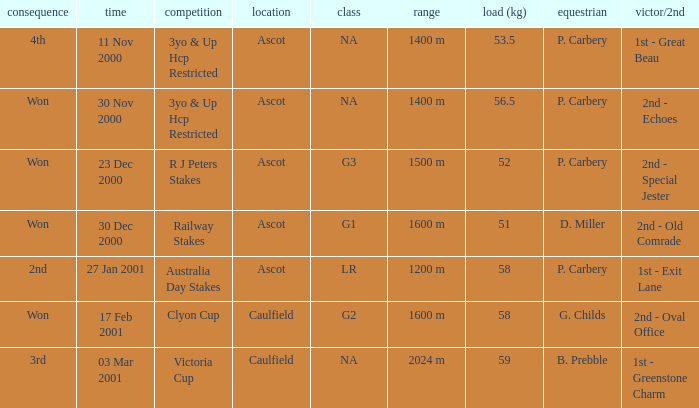What was the finish for the railway stakes race? Won. 